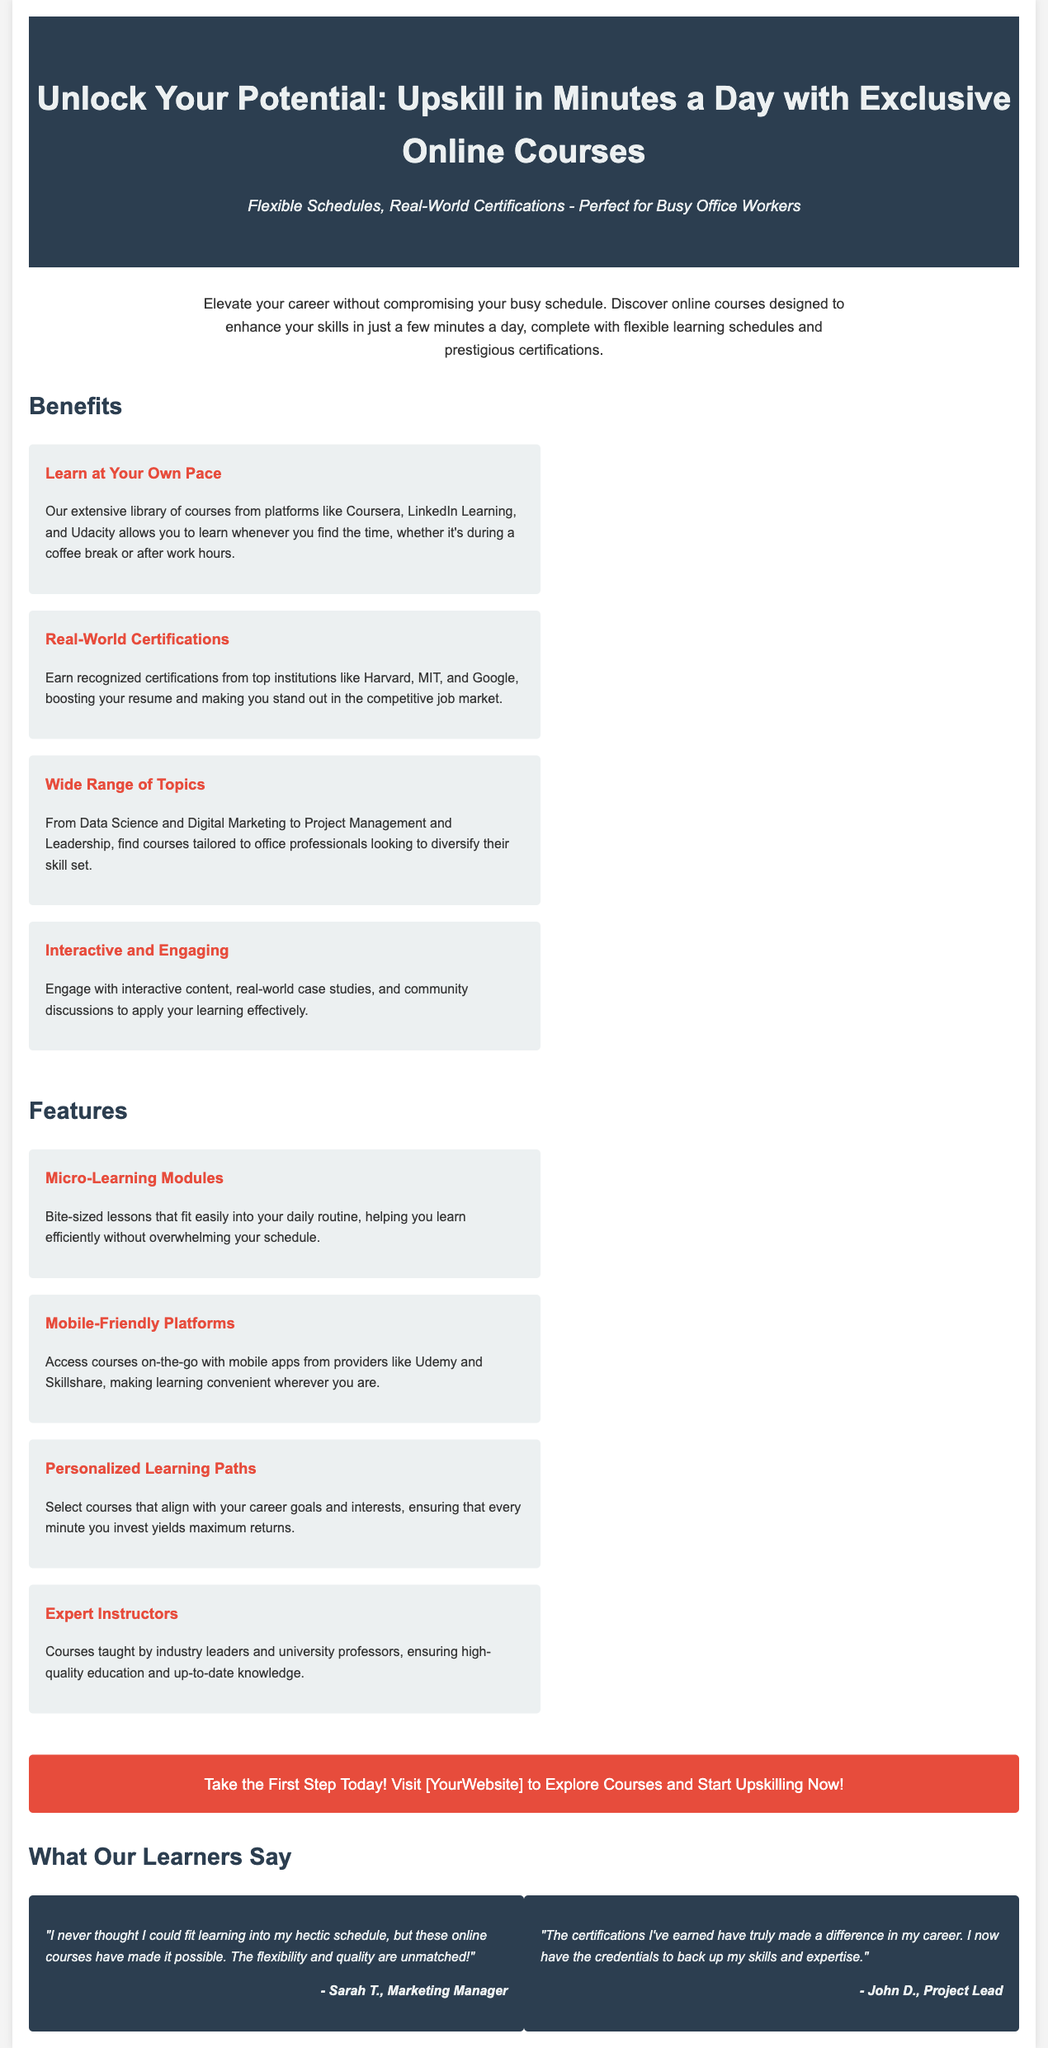What is the main benefit of these online courses? The document highlights that learners can "learn at your own pace," allowing for flexibility and convenience.
Answer: Learn at Your Own Pace Which institutions offer real-world certifications? The document mentions that certifications are from "top institutions like Harvard, MIT, and Google."
Answer: Harvard, MIT, and Google What is a feature that supports learning on-the-go? The text states "Mobile-Friendly Platforms" as a feature, explaining that you can access courses via mobile apps.
Answer: Mobile-Friendly Platforms How do the courses help with a busy schedule? The document describes "Micro-Learning Modules" as bite-sized lessons designed to fit easily into daily routines.
Answer: Micro-Learning Modules What do learners say about the course flexibility? One testimonial indicates that the courses have made learning possible despite a hectic schedule.
Answer: Flexibility How many topics are mentioned as being covered? The document references a "Wide Range of Topics," suggesting multiple subjects are available for learners.
Answer: Wide Range of Topics Who teaches the courses? The advertisement states that the courses are taught by "Expert Instructors," including industry leaders and university professors.
Answer: Expert Instructors What is recommended action for potential learners? The call to action encourages readers to "Take the First Step Today!" inviting them to explore courses.
Answer: Take the First Step Today! 